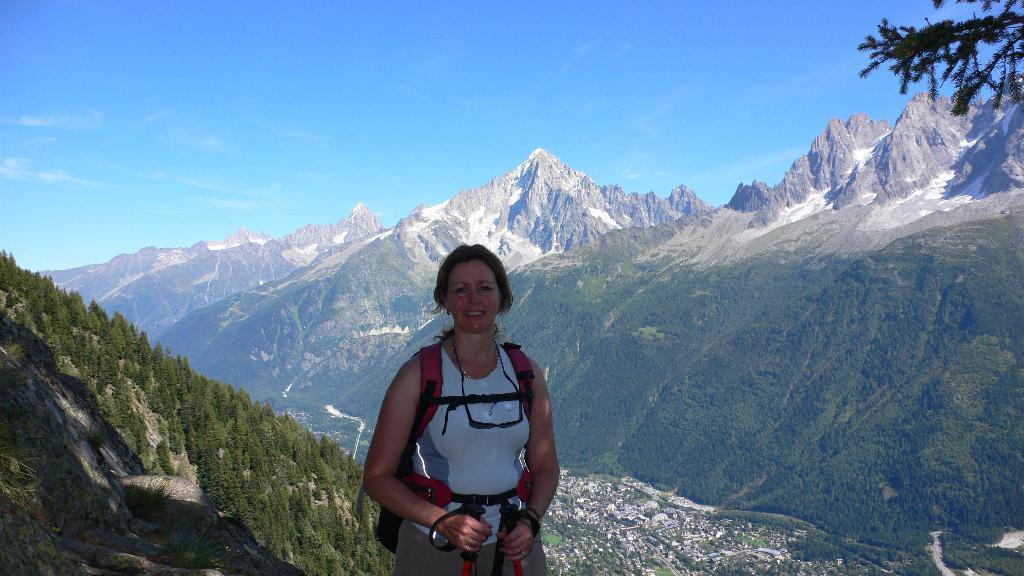How would you summarize this image in a sentence or two? In this image there is a woman standing wearing a bag and holding sticks in her hand, in the background there are mountains and the sky. 